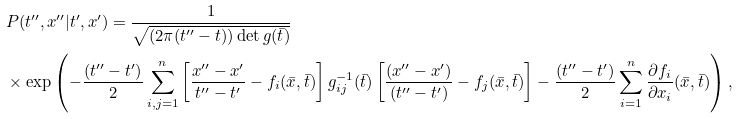Convert formula to latex. <formula><loc_0><loc_0><loc_500><loc_500>& P ( t ^ { \prime \prime } , x ^ { \prime \prime } | t ^ { \prime } , x ^ { \prime } ) = \frac { 1 } { \sqrt { ( 2 \pi ( t ^ { \prime \prime } - t ) ) \det g ( \bar { t } ) } } \\ & \times \exp \left ( - \frac { ( t ^ { \prime \prime } - t ^ { \prime } ) } { 2 } \sum _ { i , j = 1 } ^ { n } \left [ \frac { x ^ { \prime \prime } - x ^ { \prime } } { t ^ { \prime \prime } - t ^ { \prime } } - f _ { i } ( \bar { x } , \bar { t } ) \right ] g _ { i j } ^ { - 1 } ( \bar { t } ) \left [ \frac { ( x ^ { \prime \prime } - x ^ { \prime } ) } { ( t ^ { \prime \prime } - t ^ { \prime } ) } - f _ { j } ( \bar { x } , \bar { t } ) \right ] - \frac { ( t ^ { \prime \prime } - t ^ { \prime } ) } { 2 } \sum _ { i = 1 } ^ { n } \frac { \partial f _ { i } } { \partial x _ { i } } ( \bar { x } , \bar { t } ) \right ) ,</formula> 